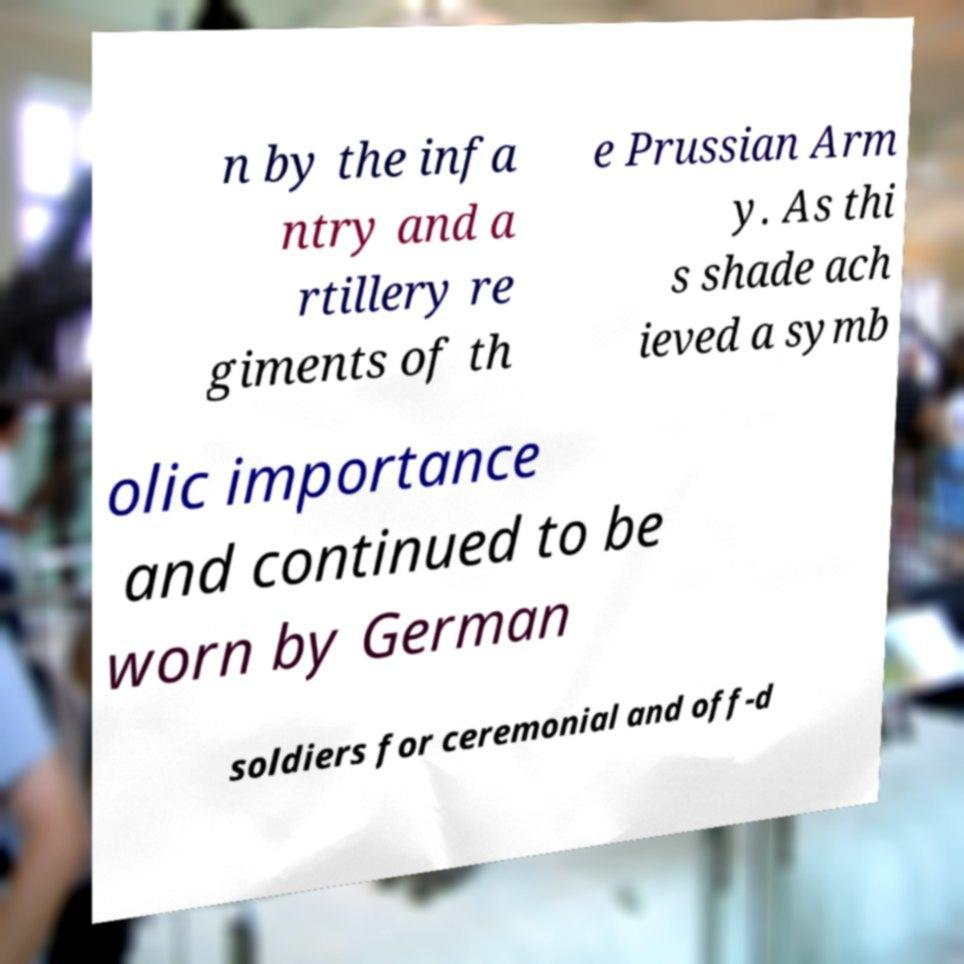Please read and relay the text visible in this image. What does it say? n by the infa ntry and a rtillery re giments of th e Prussian Arm y. As thi s shade ach ieved a symb olic importance and continued to be worn by German soldiers for ceremonial and off-d 